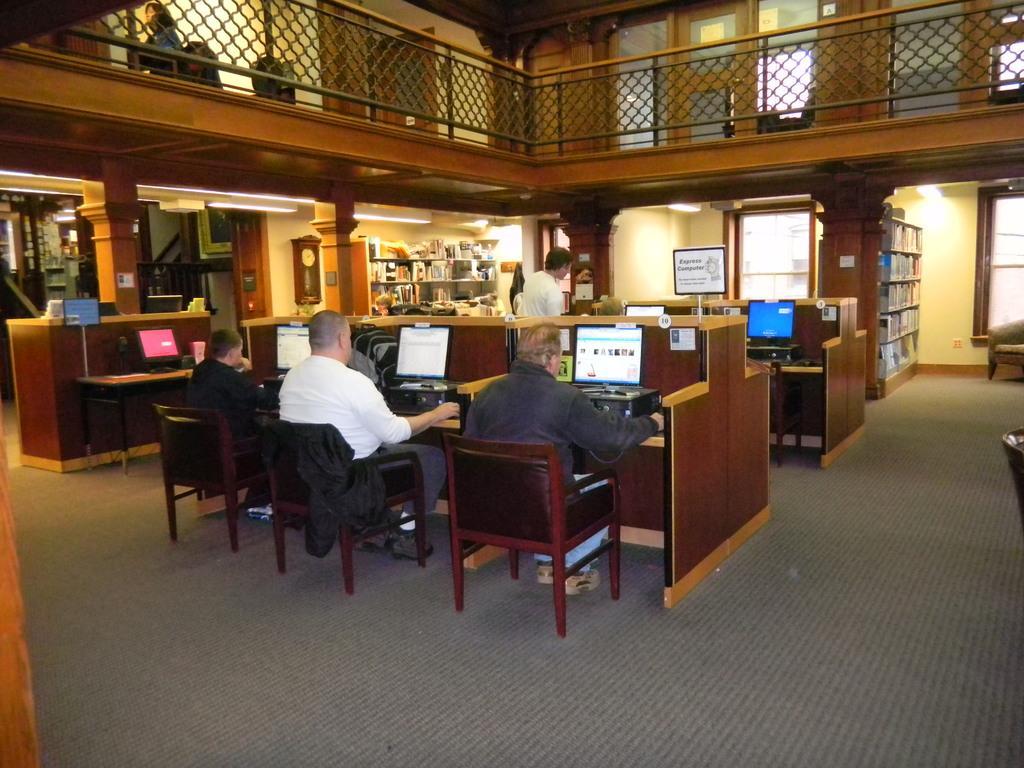How would you summarize this image in a sentence or two? In this picture we can see some cabins and some people sitting on the chairs in front of the desk of a cabin on which there are some systems and to the left there is a shelf on which some things are placed. 